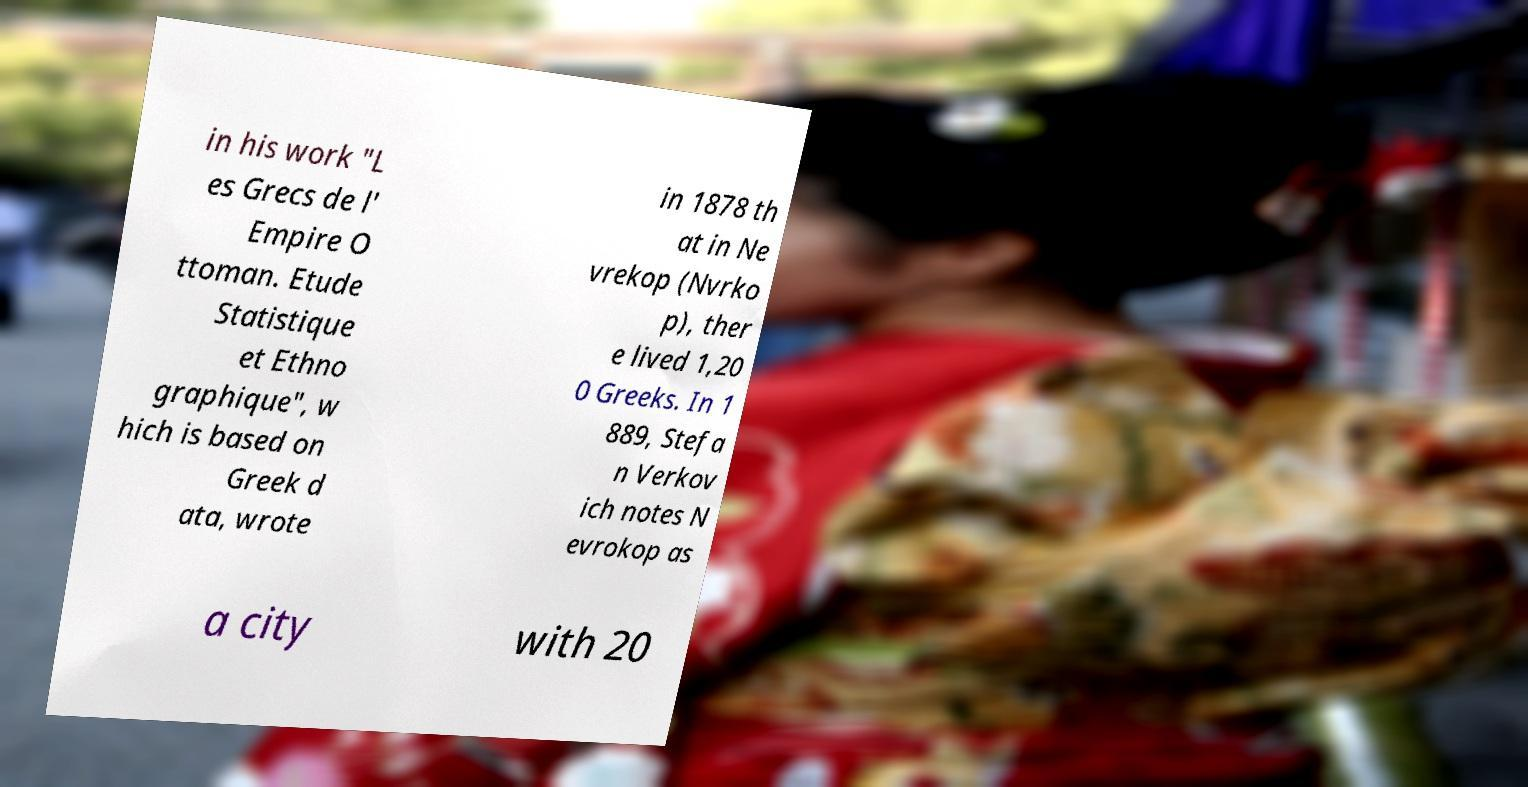Please identify and transcribe the text found in this image. in his work "L es Grecs de l' Empire O ttoman. Etude Statistique et Ethno graphique", w hich is based on Greek d ata, wrote in 1878 th at in Ne vrekop (Nvrko p), ther e lived 1,20 0 Greeks. In 1 889, Stefa n Verkov ich notes N evrokop as a city with 20 